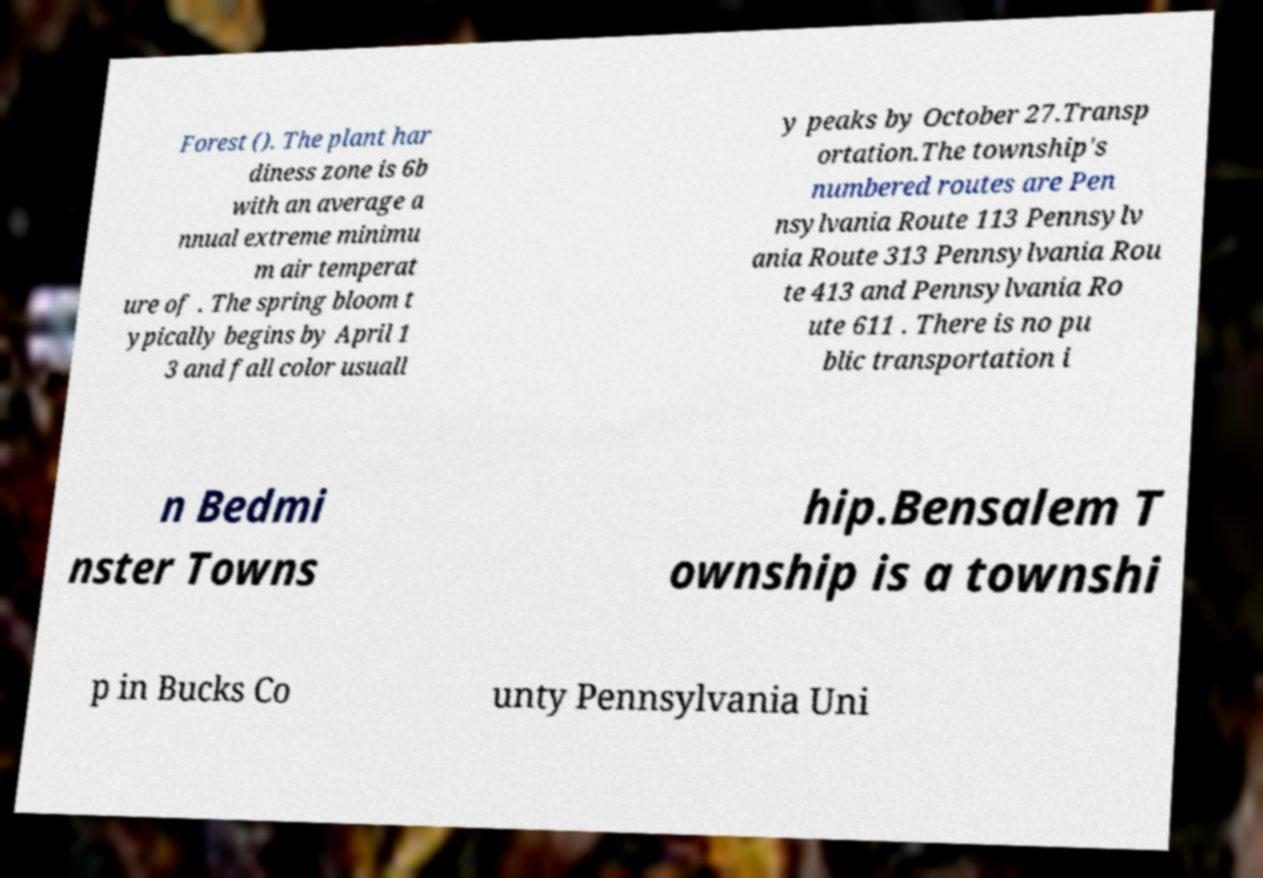I need the written content from this picture converted into text. Can you do that? Forest (). The plant har diness zone is 6b with an average a nnual extreme minimu m air temperat ure of . The spring bloom t ypically begins by April 1 3 and fall color usuall y peaks by October 27.Transp ortation.The township's numbered routes are Pen nsylvania Route 113 Pennsylv ania Route 313 Pennsylvania Rou te 413 and Pennsylvania Ro ute 611 . There is no pu blic transportation i n Bedmi nster Towns hip.Bensalem T ownship is a townshi p in Bucks Co unty Pennsylvania Uni 